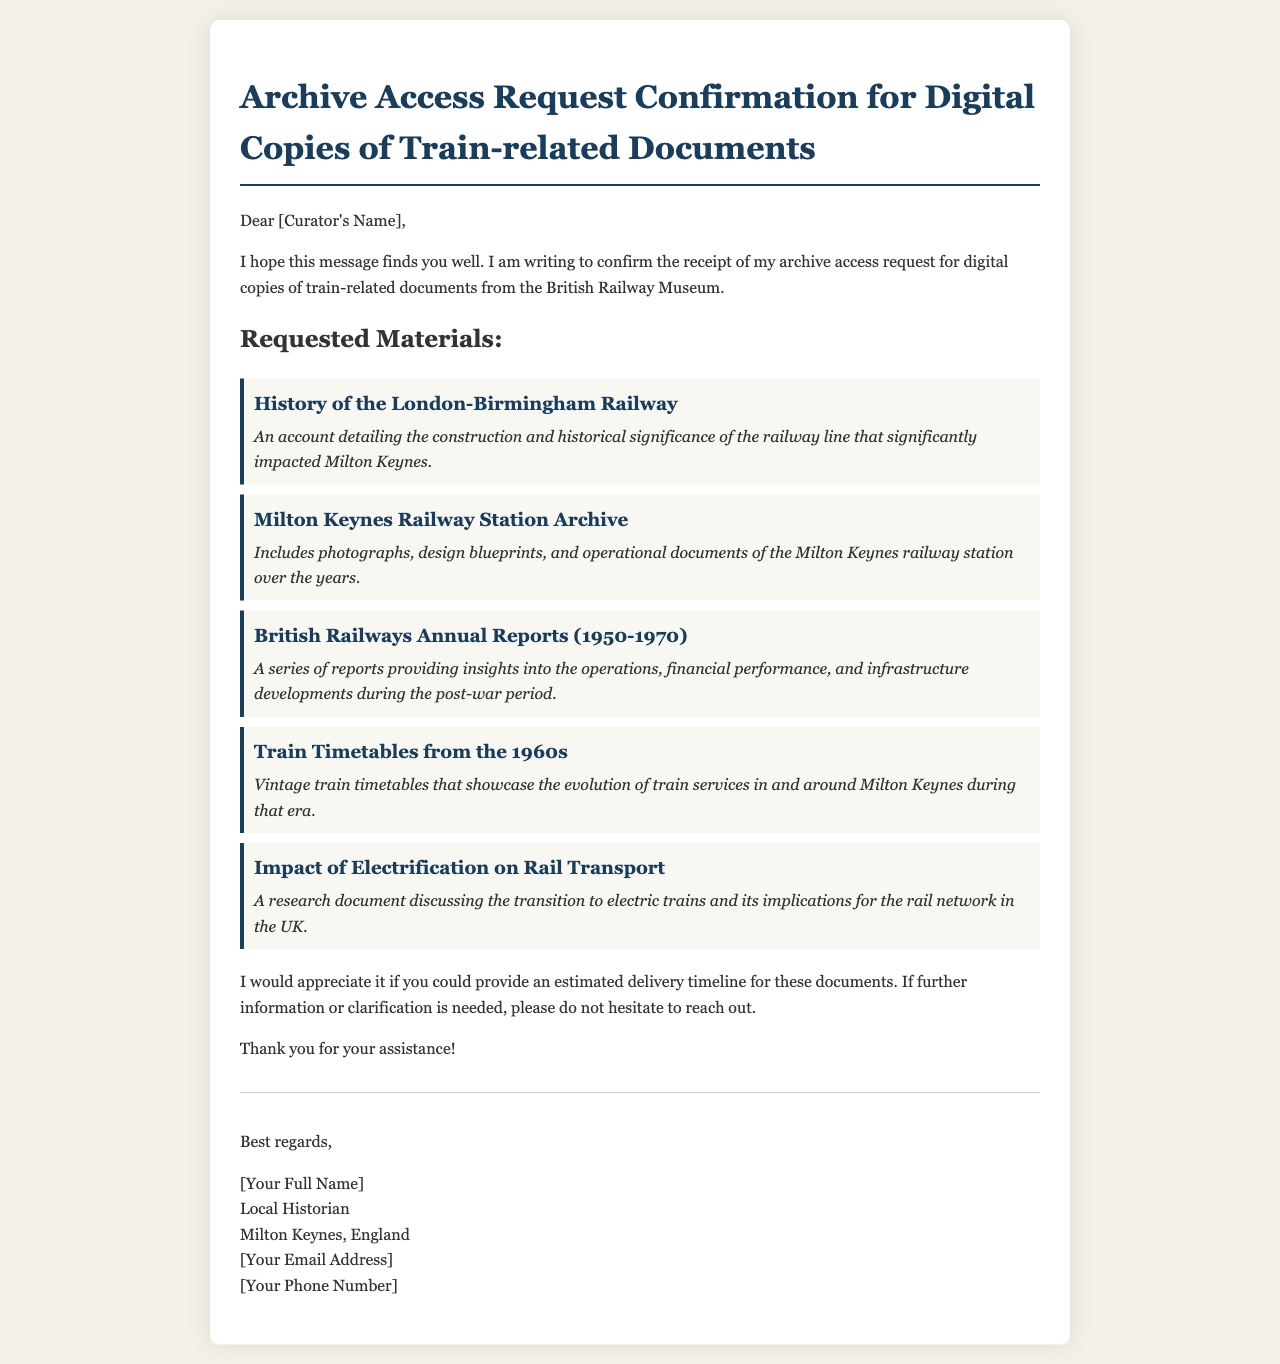what is the title of the email? The title of the email indicates the purpose of the correspondence regarding archive access request confirmation for digital copies.
Answer: Archive Access Request Confirmation for Digital Copies of Train-related Documents who is the sender of the email? The sender of the email is the individual making the archive access request, a local historian.
Answer: [Your Full Name] what type of materials were requested? The materials requested relate to train history, and the email lists several specific documents.
Answer: digital copies of train-related documents how many specific documents are listed in the request? The email provides a list of requested documents, counting each entry gives the total.
Answer: five what is one of the requested documents? The email specifies several documents; one is highlighted for clarity.
Answer: History of the London-Birmingham Railway what time period do the British Railways Annual Reports cover? The time period of the reports can be determined by the dates mentioned in the email.
Answer: 1950-1970 what information does the sender request regarding the documents? The sender seeks clarification on the expected handling time for the requested materials.
Answer: estimated delivery timeline what type of historian is the sender? The sender's professional designation is specified in the email signature.
Answer: Local Historian what should the curator do if further information is needed? The sender advises the curator on the steps to take if clarification is required.
Answer: reach out 